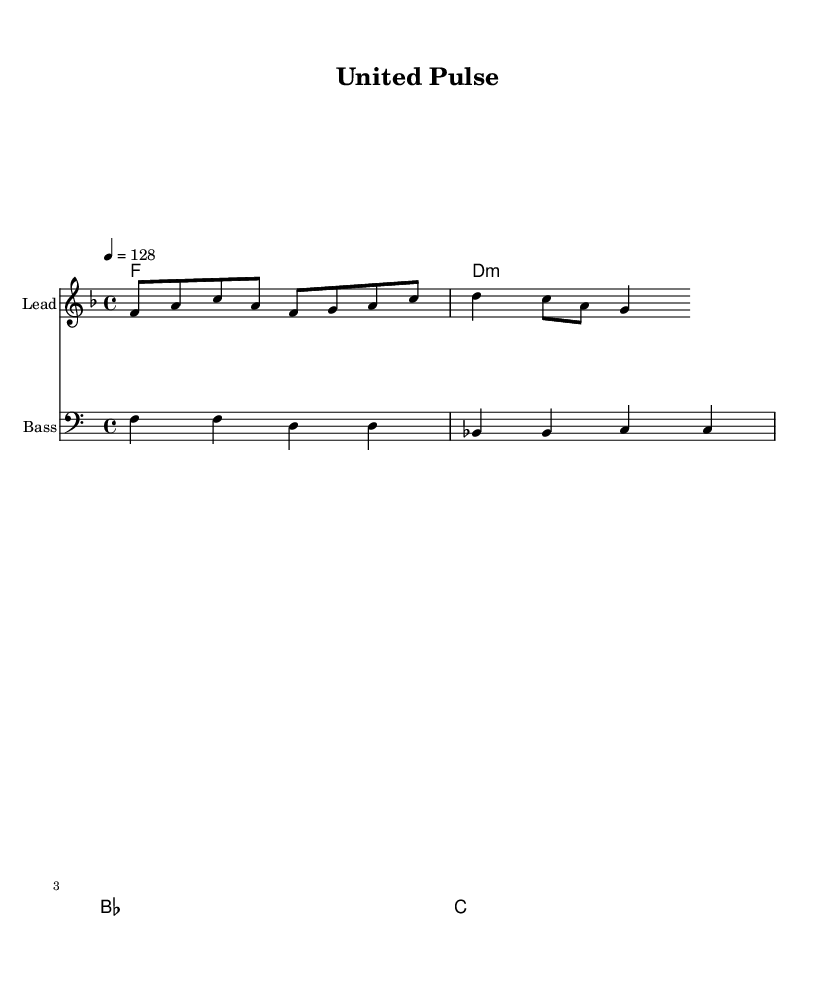What is the key signature of this music? The key signature shown at the beginning of the score indicates F major, which has one flat (B♭).
Answer: F major What is the time signature of this music? The time signature is indicated as 4/4, meaning there are four beats in each measure and a quarter note gets one beat.
Answer: 4/4 What is the tempo marking for this piece? The tempo marking indicates a speed of 128 beats per minute, specifying how fast the music should be played.
Answer: 128 How many measures are in the melody? By counting the groupings of notes and the spaces in between, the melody consists of 4 measures to match the 4/4 time signature.
Answer: 4 What is the instrument designated for the lead melody? The instrument designated for the lead part is labeled as "Lead" in the score, indicating that it is meant to carry the main theme.
Answer: Lead Which chords are used in the harmonies? The harmonies feature the chords F, D minor, B♭, and C, which are consistent with the overall tonal framework of the piece.
Answer: F, D minor, B♭, C How does the bass line correlate with the chords? The bass line provides foundational notes that align with the harmonies, reinforcing the chord tones and establishing the harmonic structure of the piece.
Answer: Aligns with harmonies 